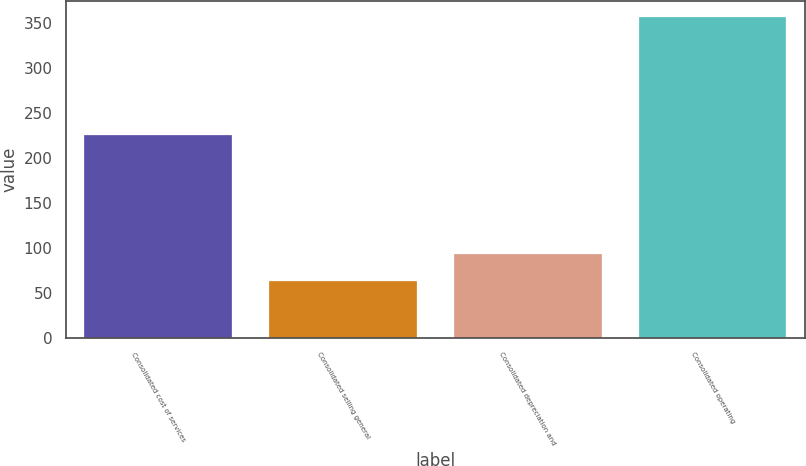Convert chart to OTSL. <chart><loc_0><loc_0><loc_500><loc_500><bar_chart><fcel>Consolidated cost of services<fcel>Consolidated selling general<fcel>Consolidated depreciation and<fcel>Consolidated operating<nl><fcel>226<fcel>63.9<fcel>93.24<fcel>357.3<nl></chart> 